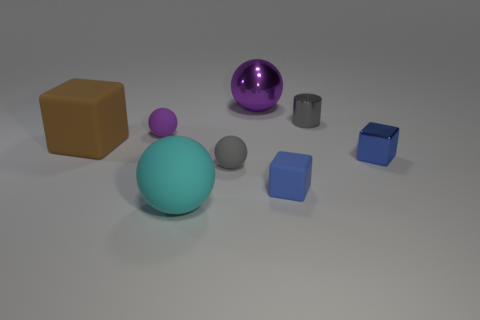Can you tell me what objects are closest to the large gray sphere? Certainly! The objects closest to the large gray sphere are a small purple shiny sphere and a medium-sized blue cube. They form a visually interesting trio with contrasting shapes and sizes. Are there any patterns or symmetry in how the objects are arranged? The arrangement of objects does not follow a strict pattern or symmetry. The objects are placed in an apparently random manner across the surface, offering a more informal and naturalistic composition that invites open interpretation. 